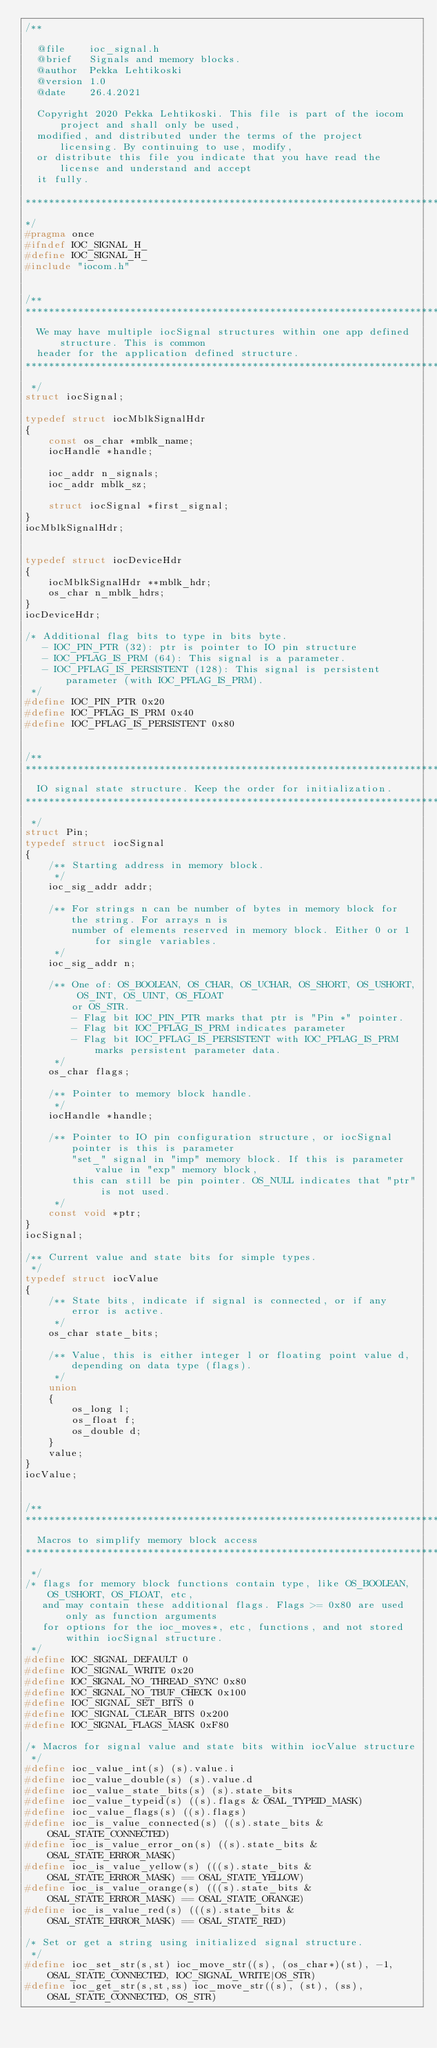Convert code to text. <code><loc_0><loc_0><loc_500><loc_500><_C_>/**

  @file    ioc_signal.h
  @brief   Signals and memory blocks.
  @author  Pekka Lehtikoski
  @version 1.0
  @date    26.4.2021

  Copyright 2020 Pekka Lehtikoski. This file is part of the iocom project and shall only be used,
  modified, and distributed under the terms of the project licensing. By continuing to use, modify,
  or distribute this file you indicate that you have read the license and understand and accept
  it fully.

****************************************************************************************************
*/
#pragma once
#ifndef IOC_SIGNAL_H_
#define IOC_SIGNAL_H_
#include "iocom.h"


/**
****************************************************************************************************
  We may have multiple iocSignal structures within one app defined structure. This is common
  header for the application defined structure.
****************************************************************************************************
 */
struct iocSignal;

typedef struct iocMblkSignalHdr
{
    const os_char *mblk_name;
    iocHandle *handle;

    ioc_addr n_signals;
    ioc_addr mblk_sz;

    struct iocSignal *first_signal;
}
iocMblkSignalHdr;


typedef struct iocDeviceHdr
{
    iocMblkSignalHdr **mblk_hdr;
    os_char n_mblk_hdrs;
}
iocDeviceHdr;

/* Additional flag bits to type in bits byte.
   - IOC_PIN_PTR (32): ptr is pointer to IO pin structure
   - IOC_PFLAG_IS_PRM (64): This signal is a parameter.
   - IOC_PFLAG_IS_PERSISTENT (128): This signal is persistent parameter (with IOC_PFLAG_IS_PRM).
 */
#define IOC_PIN_PTR 0x20
#define IOC_PFLAG_IS_PRM 0x40
#define IOC_PFLAG_IS_PERSISTENT 0x80


/**
****************************************************************************************************
  IO signal state structure. Keep the order for initialization.
****************************************************************************************************
 */
struct Pin;
typedef struct iocSignal
{
    /** Starting address in memory block.
     */
    ioc_sig_addr addr;

    /** For strings n can be number of bytes in memory block for the string. For arrays n is
        number of elements reserved in memory block. Either 0 or 1 for single variables.
     */
    ioc_sig_addr n;

    /** One of: OS_BOOLEAN, OS_CHAR, OS_UCHAR, OS_SHORT, OS_USHORT, OS_INT, OS_UINT, OS_FLOAT
        or OS_STR.
        - Flag bit IOC_PIN_PTR marks that ptr is "Pin *" pointer.
        - Flag bit IOC_PFLAG_IS_PRM indicates parameter
        - Flag bit IOC_PFLAG_IS_PERSISTENT with IOC_PFLAG_IS_PRM marks persistent parameter data.
     */
    os_char flags;

    /** Pointer to memory block handle.
     */
    iocHandle *handle;

    /** Pointer to IO pin configuration structure, or iocSignal pointer is this is parameter
        "set_" signal in "imp" memory block. If this is parameter value in "exp" memory block,
        this can still be pin pointer. OS_NULL indicates that "ptr" is not used.
     */
    const void *ptr;
}
iocSignal;

/** Current value and state bits for simple types.
 */
typedef struct iocValue
{
    /** State bits, indicate if signal is connected, or if any error is active.
     */
    os_char state_bits;

    /** Value, this is either integer l or floating point value d, depending on data type (flags).
     */
    union
    {
        os_long l;
        os_float f;
        os_double d;
    }
    value;
}
iocValue;


/**
****************************************************************************************************
  Macros to simplify memory block access
****************************************************************************************************
 */
/* flags for memory block functions contain type, like OS_BOOLEAN, OS_USHORT, OS_FLOAT, etc,
   and may contain these additional flags. Flags >= 0x80 are used only as function arguments
   for options for the ioc_moves*, etc, functions, and not stored within iocSignal structure.
 */
#define IOC_SIGNAL_DEFAULT 0
#define IOC_SIGNAL_WRITE 0x20
#define IOC_SIGNAL_NO_THREAD_SYNC 0x80
#define IOC_SIGNAL_NO_TBUF_CHECK 0x100
#define IOC_SIGNAL_SET_BITS 0
#define IOC_SIGNAL_CLEAR_BITS 0x200
#define IOC_SIGNAL_FLAGS_MASK 0xF80

/* Macros for signal value and state bits within iocValue structure
 */
#define ioc_value_int(s) (s).value.i
#define ioc_value_double(s) (s).value.d
#define ioc_value_state_bits(s) (s).state_bits
#define ioc_value_typeid(s) ((s).flags & OSAL_TYPEID_MASK)
#define ioc_value_flags(s) ((s).flags)
#define ioc_is_value_connected(s) ((s).state_bits & OSAL_STATE_CONNECTED)
#define ioc_is_value_error_on(s) ((s).state_bits & OSAL_STATE_ERROR_MASK)
#define ioc_is_value_yellow(s) (((s).state_bits & OSAL_STATE_ERROR_MASK) == OSAL_STATE_YELLOW)
#define ioc_is_value_orange(s) (((s).state_bits & OSAL_STATE_ERROR_MASK) == OSAL_STATE_ORANGE)
#define ioc_is_value_red(s) (((s).state_bits & OSAL_STATE_ERROR_MASK) == OSAL_STATE_RED)

/* Set or get a string using initialized signal structure.
 */
#define ioc_set_str(s,st) ioc_move_str((s), (os_char*)(st), -1, OSAL_STATE_CONNECTED, IOC_SIGNAL_WRITE|OS_STR)
#define ioc_get_str(s,st,ss) ioc_move_str((s), (st), (ss), OSAL_STATE_CONNECTED, OS_STR)
</code> 